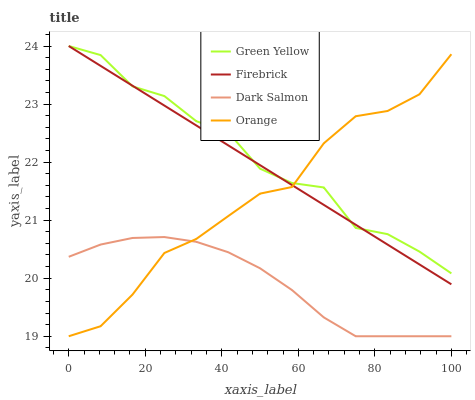Does Dark Salmon have the minimum area under the curve?
Answer yes or no. Yes. Does Green Yellow have the maximum area under the curve?
Answer yes or no. Yes. Does Firebrick have the minimum area under the curve?
Answer yes or no. No. Does Firebrick have the maximum area under the curve?
Answer yes or no. No. Is Firebrick the smoothest?
Answer yes or no. Yes. Is Green Yellow the roughest?
Answer yes or no. Yes. Is Green Yellow the smoothest?
Answer yes or no. No. Is Firebrick the roughest?
Answer yes or no. No. Does Orange have the lowest value?
Answer yes or no. Yes. Does Firebrick have the lowest value?
Answer yes or no. No. Does Green Yellow have the highest value?
Answer yes or no. Yes. Does Dark Salmon have the highest value?
Answer yes or no. No. Is Dark Salmon less than Green Yellow?
Answer yes or no. Yes. Is Firebrick greater than Dark Salmon?
Answer yes or no. Yes. Does Firebrick intersect Orange?
Answer yes or no. Yes. Is Firebrick less than Orange?
Answer yes or no. No. Is Firebrick greater than Orange?
Answer yes or no. No. Does Dark Salmon intersect Green Yellow?
Answer yes or no. No. 